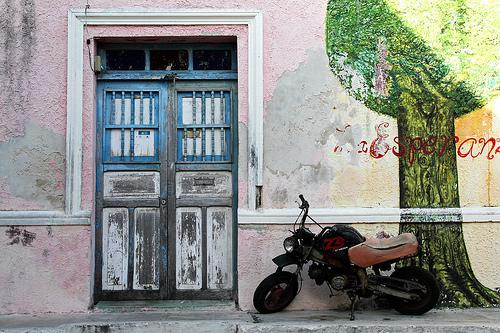Question: what vehicle is pictured?
Choices:
A. Car.
B. Motorcycle.
C. Bus.
D. Taxi.
Answer with the letter. Answer: B Question: what color is the letter Z?
Choices:
A. Black.
B. White.
C. Red.
D. Blue.
Answer with the letter. Answer: C Question: where is the motorcycle facing?
Choices:
A. The street.
B. The ocean.
C. Left.
D. Right.
Answer with the letter. Answer: C Question: what is painted on the wall with green?
Choices:
A. Money.
B. A car.
C. An alligator.
D. Tree.
Answer with the letter. Answer: D Question: what material is the door?
Choices:
A. Metal.
B. Glass.
C. Wood.
D. Plastic.
Answer with the letter. Answer: C 